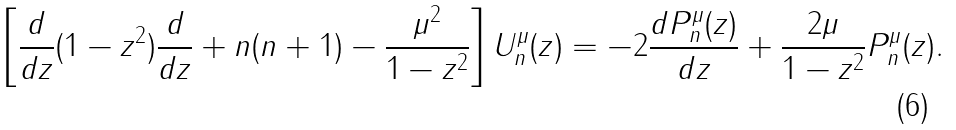<formula> <loc_0><loc_0><loc_500><loc_500>\left [ \frac { d } { d z } ( 1 - z ^ { 2 } ) \frac { d } { d z } + n ( n + 1 ) - \frac { \mu ^ { 2 } } { 1 - z ^ { 2 } } \right ] U _ { n } ^ { \mu } ( z ) = - 2 \frac { d P _ { n } ^ { \mu } ( z ) } { d z } + \frac { 2 \mu } { 1 - z ^ { 2 } } P _ { n } ^ { \mu } ( z ) .</formula> 